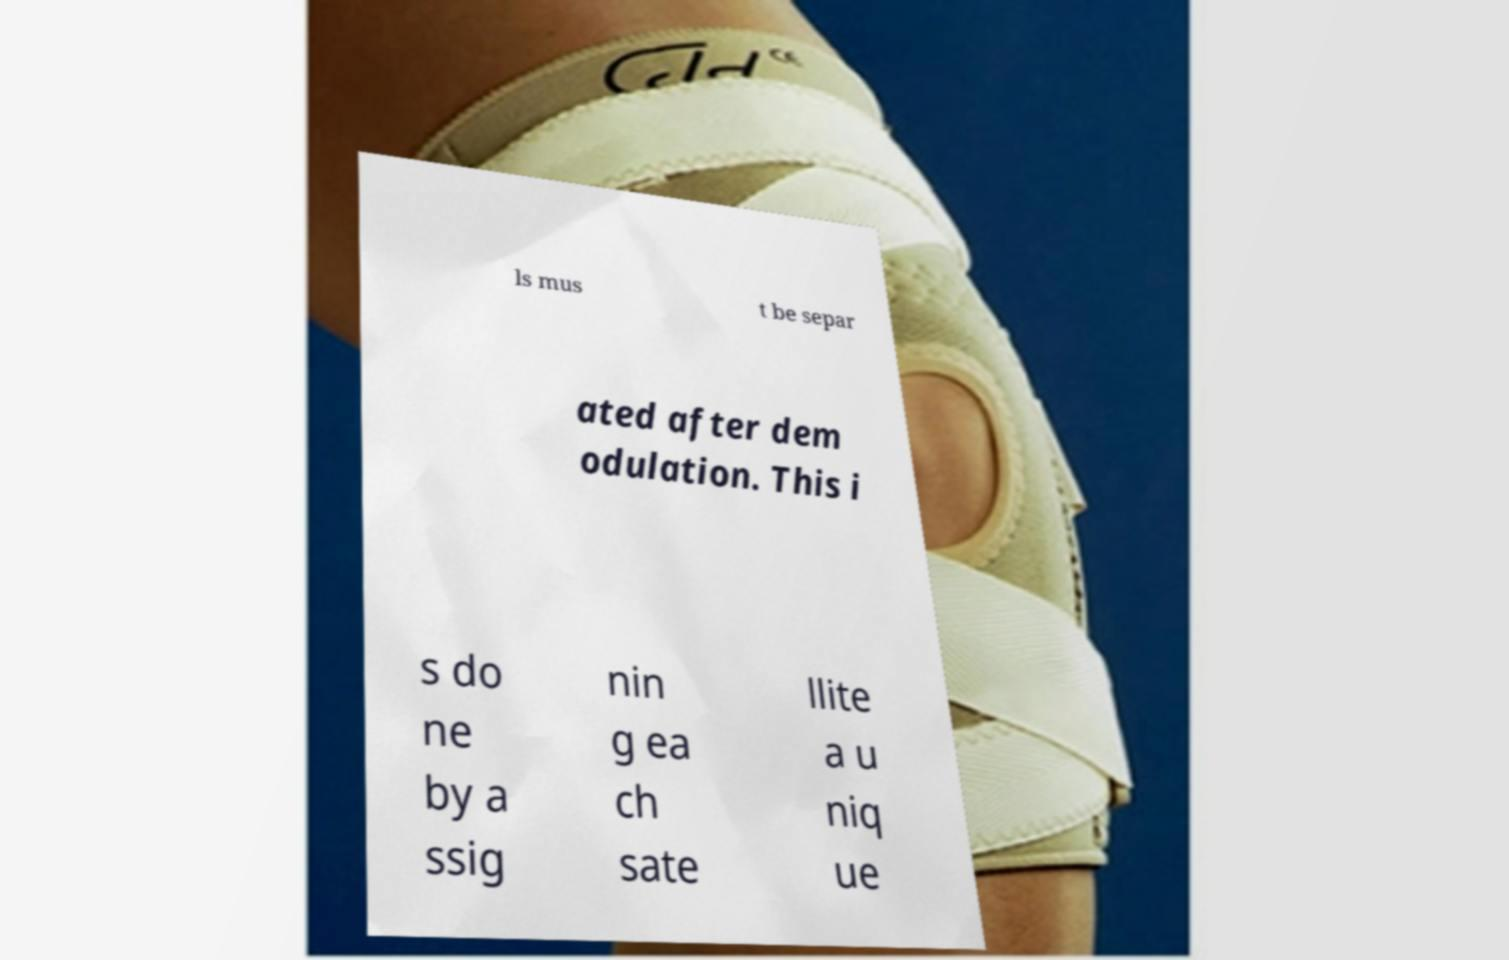I need the written content from this picture converted into text. Can you do that? ls mus t be separ ated after dem odulation. This i s do ne by a ssig nin g ea ch sate llite a u niq ue 